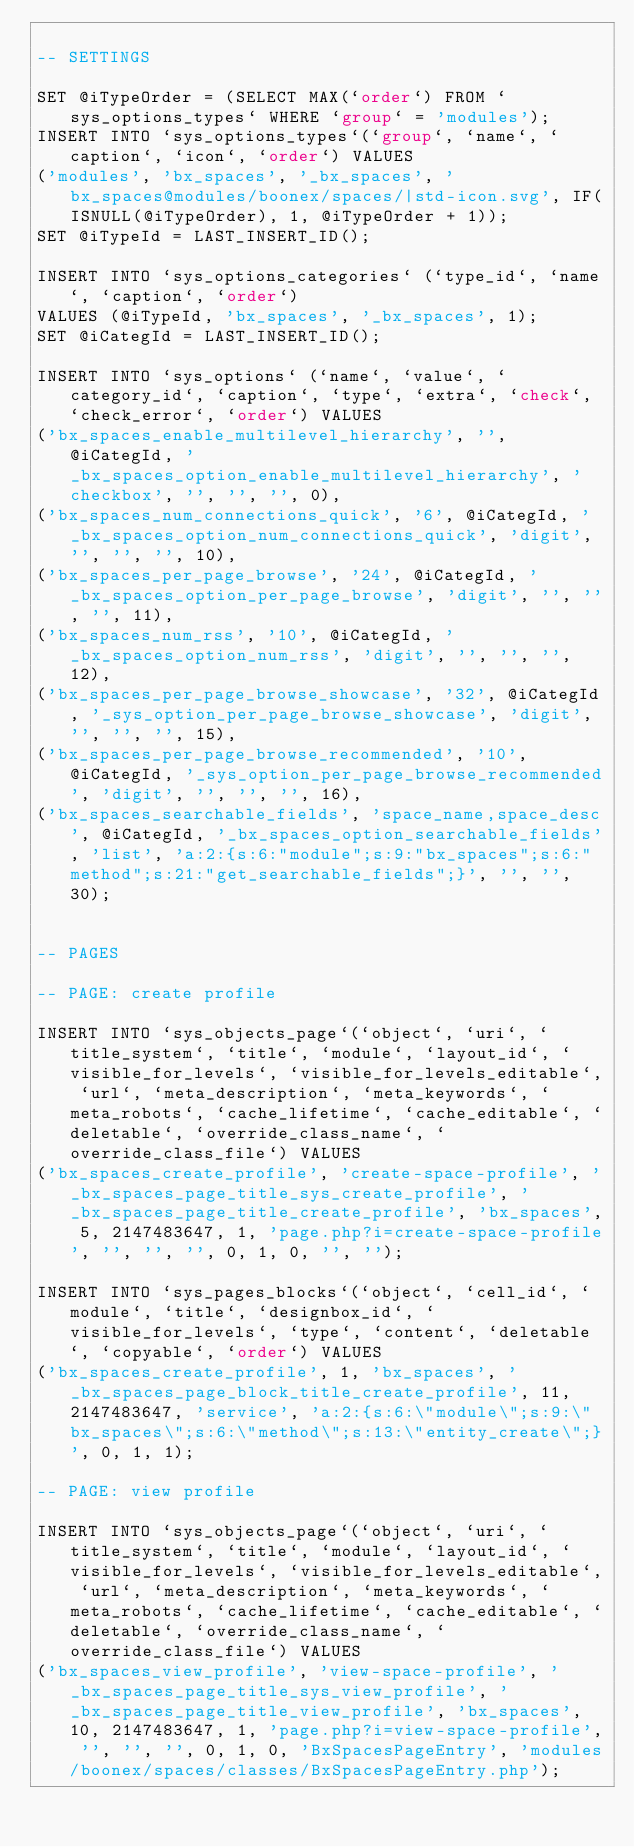<code> <loc_0><loc_0><loc_500><loc_500><_SQL_>
-- SETTINGS

SET @iTypeOrder = (SELECT MAX(`order`) FROM `sys_options_types` WHERE `group` = 'modules');
INSERT INTO `sys_options_types`(`group`, `name`, `caption`, `icon`, `order`) VALUES 
('modules', 'bx_spaces', '_bx_spaces', 'bx_spaces@modules/boonex/spaces/|std-icon.svg', IF(ISNULL(@iTypeOrder), 1, @iTypeOrder + 1));
SET @iTypeId = LAST_INSERT_ID();

INSERT INTO `sys_options_categories` (`type_id`, `name`, `caption`, `order`)
VALUES (@iTypeId, 'bx_spaces', '_bx_spaces', 1);
SET @iCategId = LAST_INSERT_ID();

INSERT INTO `sys_options` (`name`, `value`, `category_id`, `caption`, `type`, `extra`, `check`, `check_error`, `order`) VALUES
('bx_spaces_enable_multilevel_hierarchy', '', @iCategId, '_bx_spaces_option_enable_multilevel_hierarchy', 'checkbox', '', '', '', 0),
('bx_spaces_num_connections_quick', '6', @iCategId, '_bx_spaces_option_num_connections_quick', 'digit', '', '', '', 10),
('bx_spaces_per_page_browse', '24', @iCategId, '_bx_spaces_option_per_page_browse', 'digit', '', '', '', 11),
('bx_spaces_num_rss', '10', @iCategId, '_bx_spaces_option_num_rss', 'digit', '', '', '', 12),
('bx_spaces_per_page_browse_showcase', '32', @iCategId, '_sys_option_per_page_browse_showcase', 'digit', '', '', '', 15),
('bx_spaces_per_page_browse_recommended', '10', @iCategId, '_sys_option_per_page_browse_recommended', 'digit', '', '', '', 16),
('bx_spaces_searchable_fields', 'space_name,space_desc', @iCategId, '_bx_spaces_option_searchable_fields', 'list', 'a:2:{s:6:"module";s:9:"bx_spaces";s:6:"method";s:21:"get_searchable_fields";}', '', '', 30);


-- PAGES

-- PAGE: create profile

INSERT INTO `sys_objects_page`(`object`, `uri`, `title_system`, `title`, `module`, `layout_id`, `visible_for_levels`, `visible_for_levels_editable`, `url`, `meta_description`, `meta_keywords`, `meta_robots`, `cache_lifetime`, `cache_editable`, `deletable`, `override_class_name`, `override_class_file`) VALUES 
('bx_spaces_create_profile', 'create-space-profile', '_bx_spaces_page_title_sys_create_profile', '_bx_spaces_page_title_create_profile', 'bx_spaces', 5, 2147483647, 1, 'page.php?i=create-space-profile', '', '', '', 0, 1, 0, '', '');

INSERT INTO `sys_pages_blocks`(`object`, `cell_id`, `module`, `title`, `designbox_id`, `visible_for_levels`, `type`, `content`, `deletable`, `copyable`, `order`) VALUES 
('bx_spaces_create_profile', 1, 'bx_spaces', '_bx_spaces_page_block_title_create_profile', 11, 2147483647, 'service', 'a:2:{s:6:\"module\";s:9:\"bx_spaces\";s:6:\"method\";s:13:\"entity_create\";}', 0, 1, 1);

-- PAGE: view profile

INSERT INTO `sys_objects_page`(`object`, `uri`, `title_system`, `title`, `module`, `layout_id`, `visible_for_levels`, `visible_for_levels_editable`, `url`, `meta_description`, `meta_keywords`, `meta_robots`, `cache_lifetime`, `cache_editable`, `deletable`, `override_class_name`, `override_class_file`) VALUES 
('bx_spaces_view_profile', 'view-space-profile', '_bx_spaces_page_title_sys_view_profile', '_bx_spaces_page_title_view_profile', 'bx_spaces', 10, 2147483647, 1, 'page.php?i=view-space-profile', '', '', '', 0, 1, 0, 'BxSpacesPageEntry', 'modules/boonex/spaces/classes/BxSpacesPageEntry.php');
</code> 